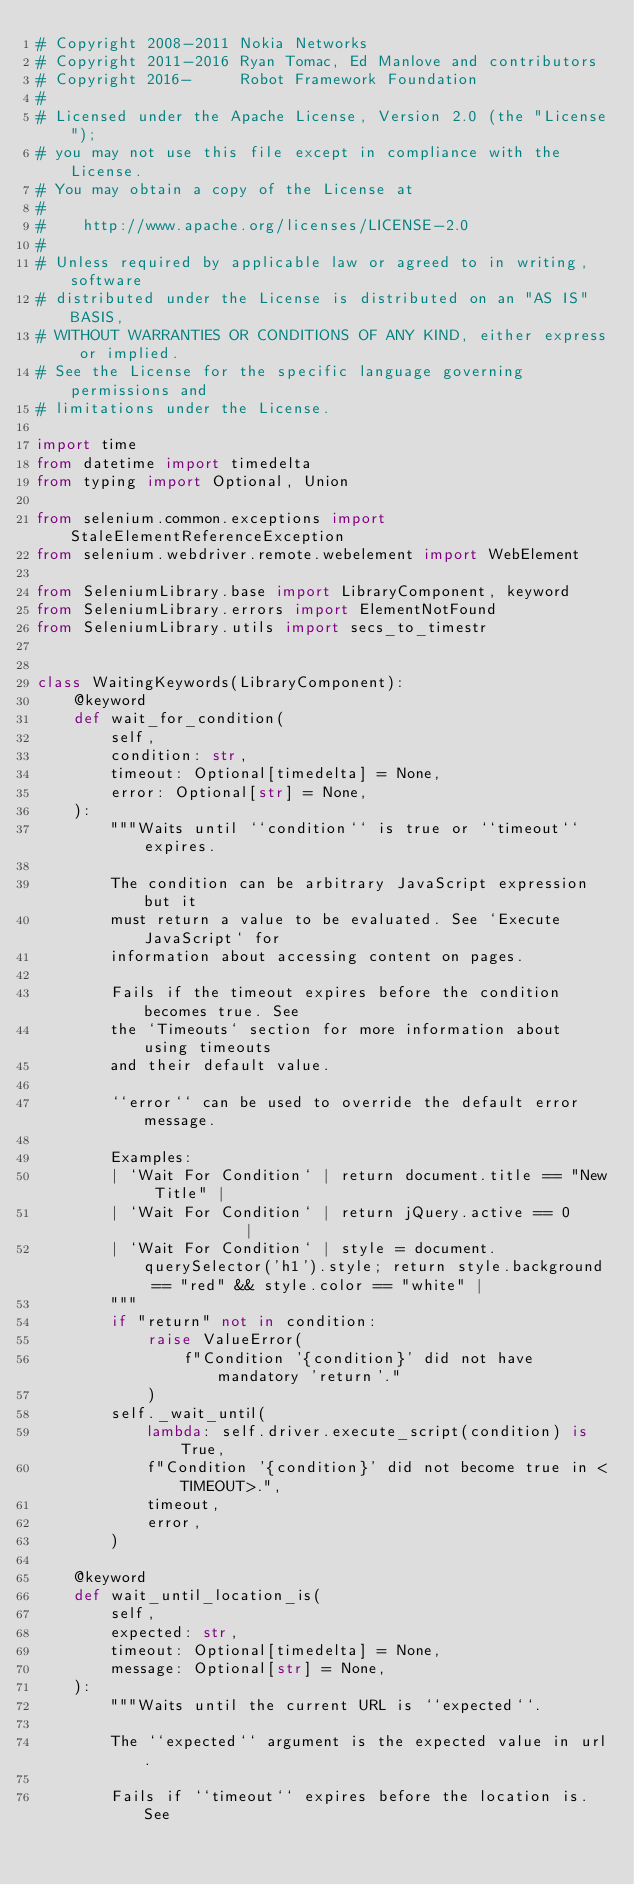Convert code to text. <code><loc_0><loc_0><loc_500><loc_500><_Python_># Copyright 2008-2011 Nokia Networks
# Copyright 2011-2016 Ryan Tomac, Ed Manlove and contributors
# Copyright 2016-     Robot Framework Foundation
#
# Licensed under the Apache License, Version 2.0 (the "License");
# you may not use this file except in compliance with the License.
# You may obtain a copy of the License at
#
#    http://www.apache.org/licenses/LICENSE-2.0
#
# Unless required by applicable law or agreed to in writing, software
# distributed under the License is distributed on an "AS IS" BASIS,
# WITHOUT WARRANTIES OR CONDITIONS OF ANY KIND, either express or implied.
# See the License for the specific language governing permissions and
# limitations under the License.

import time
from datetime import timedelta
from typing import Optional, Union

from selenium.common.exceptions import StaleElementReferenceException
from selenium.webdriver.remote.webelement import WebElement

from SeleniumLibrary.base import LibraryComponent, keyword
from SeleniumLibrary.errors import ElementNotFound
from SeleniumLibrary.utils import secs_to_timestr


class WaitingKeywords(LibraryComponent):
    @keyword
    def wait_for_condition(
        self,
        condition: str,
        timeout: Optional[timedelta] = None,
        error: Optional[str] = None,
    ):
        """Waits until ``condition`` is true or ``timeout`` expires.

        The condition can be arbitrary JavaScript expression but it
        must return a value to be evaluated. See `Execute JavaScript` for
        information about accessing content on pages.

        Fails if the timeout expires before the condition becomes true. See
        the `Timeouts` section for more information about using timeouts
        and their default value.

        ``error`` can be used to override the default error message.

        Examples:
        | `Wait For Condition` | return document.title == "New Title" |
        | `Wait For Condition` | return jQuery.active == 0            |
        | `Wait For Condition` | style = document.querySelector('h1').style; return style.background == "red" && style.color == "white" |
        """
        if "return" not in condition:
            raise ValueError(
                f"Condition '{condition}' did not have mandatory 'return'."
            )
        self._wait_until(
            lambda: self.driver.execute_script(condition) is True,
            f"Condition '{condition}' did not become true in <TIMEOUT>.",
            timeout,
            error,
        )

    @keyword
    def wait_until_location_is(
        self,
        expected: str,
        timeout: Optional[timedelta] = None,
        message: Optional[str] = None,
    ):
        """Waits until the current URL is ``expected``.

        The ``expected`` argument is the expected value in url.

        Fails if ``timeout`` expires before the location is. See</code> 